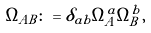Convert formula to latex. <formula><loc_0><loc_0><loc_500><loc_500>\Omega _ { A B } \colon = \delta _ { a b } \Omega ^ { a } _ { A } \Omega ^ { b } _ { B } ,</formula> 